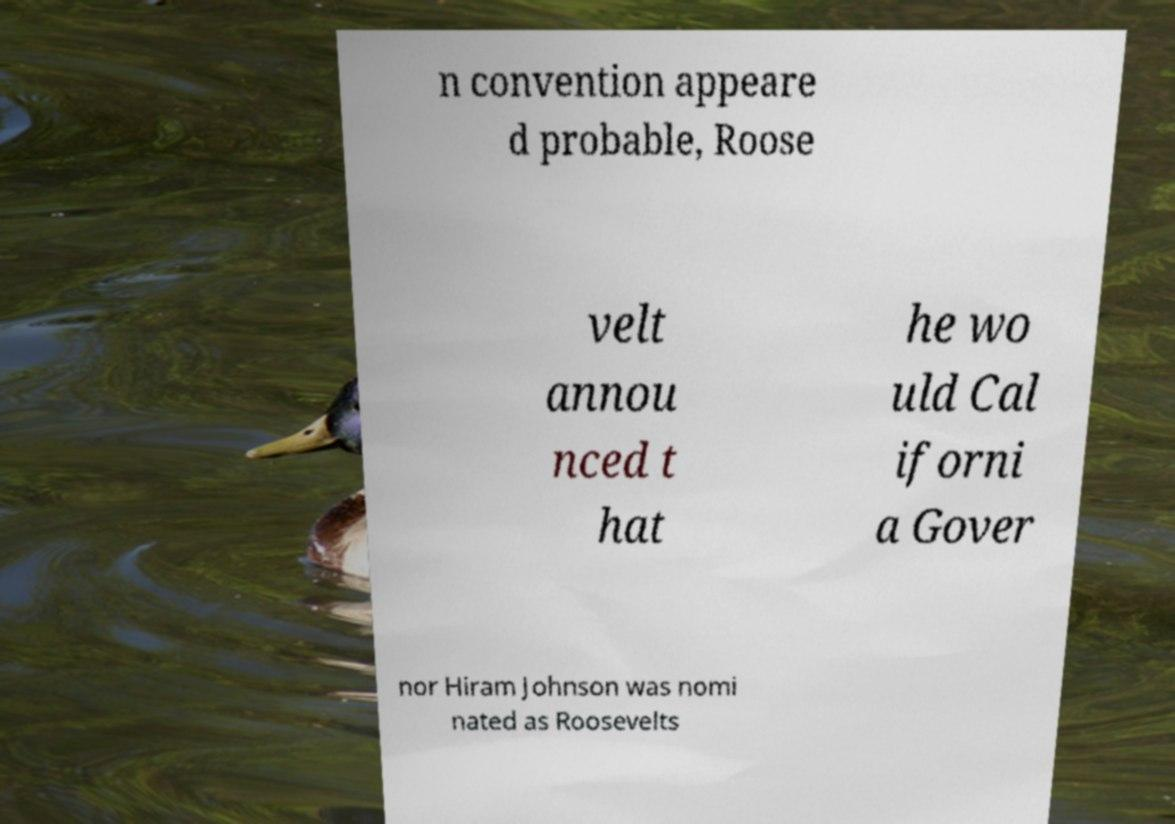What messages or text are displayed in this image? I need them in a readable, typed format. n convention appeare d probable, Roose velt annou nced t hat he wo uld Cal iforni a Gover nor Hiram Johnson was nomi nated as Roosevelts 